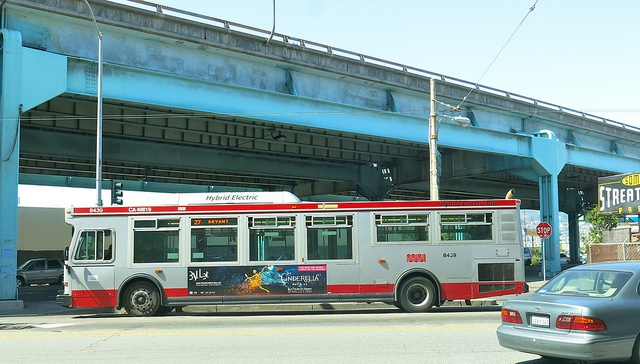Describe the objects in this image and their specific colors. I can see bus in darkgreen, darkgray, lightgray, black, and gray tones, car in darkgreen, lightblue, darkgray, and gray tones, car in darkgreen, black, teal, purple, and gray tones, stop sign in darkgreen, brown, darkgray, and maroon tones, and car in darkgreen, black, gray, and purple tones in this image. 